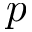Convert formula to latex. <formula><loc_0><loc_0><loc_500><loc_500>p</formula> 